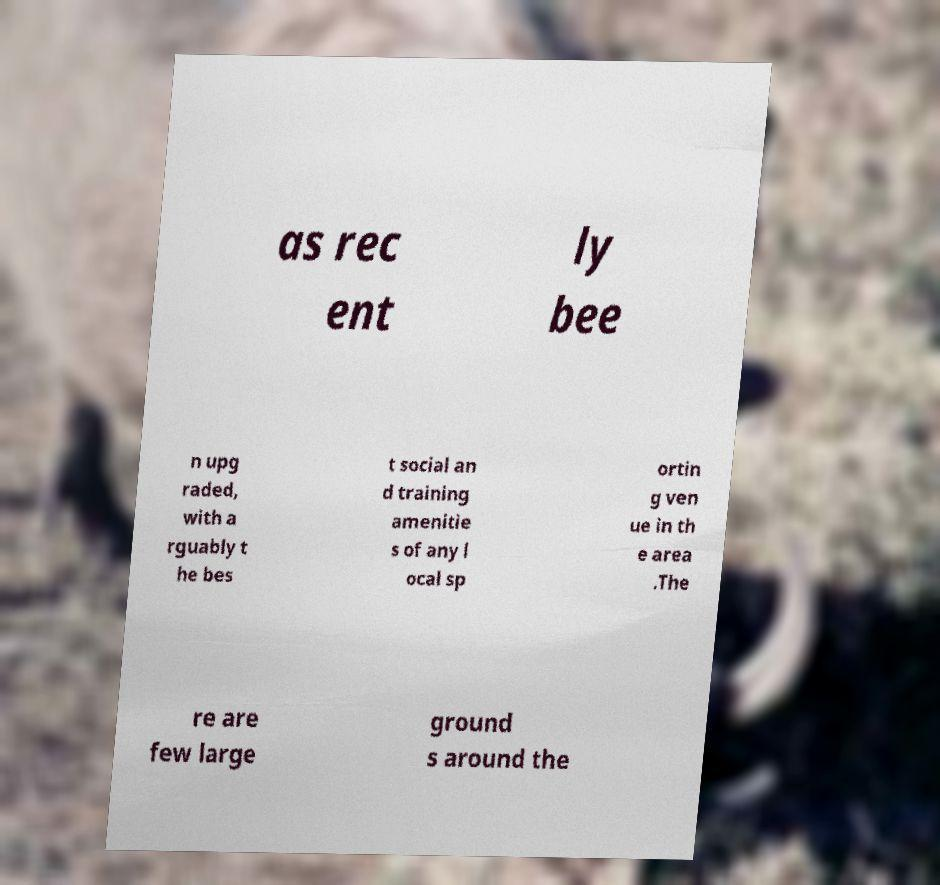Please identify and transcribe the text found in this image. as rec ent ly bee n upg raded, with a rguably t he bes t social an d training amenitie s of any l ocal sp ortin g ven ue in th e area .The re are few large ground s around the 